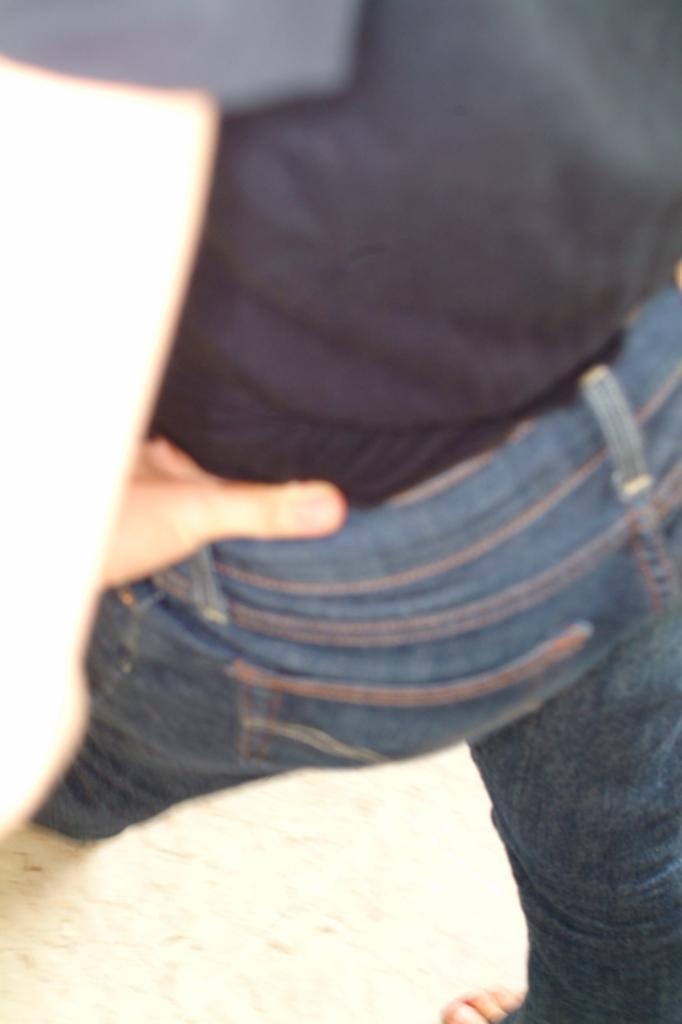In one or two sentences, can you explain what this image depicts? At the bottom of the image there is a floor. In the middle of the image a man is walking on the floor. He has worn a T-shirt and a jeans pant. 